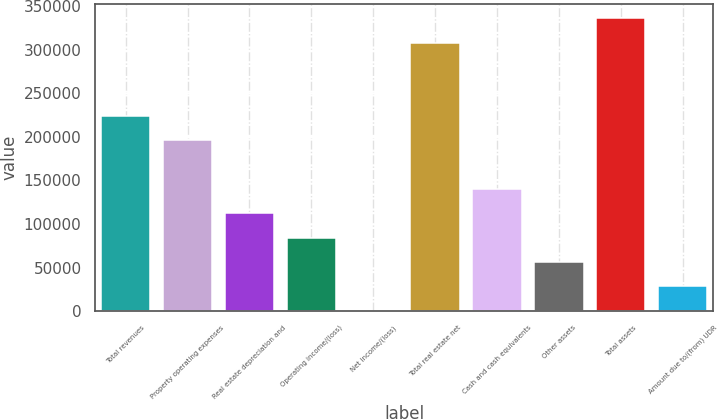<chart> <loc_0><loc_0><loc_500><loc_500><bar_chart><fcel>Total revenues<fcel>Property operating expenses<fcel>Real estate depreciation and<fcel>Operating income/(loss)<fcel>Net income/(loss)<fcel>Total real estate net<fcel>Cash and cash equivalents<fcel>Other assets<fcel>Total assets<fcel>Amount due to/(from) UDR<nl><fcel>224187<fcel>196257<fcel>112466<fcel>84535.2<fcel>744<fcel>307978<fcel>140396<fcel>56604.8<fcel>335909<fcel>28674.4<nl></chart> 